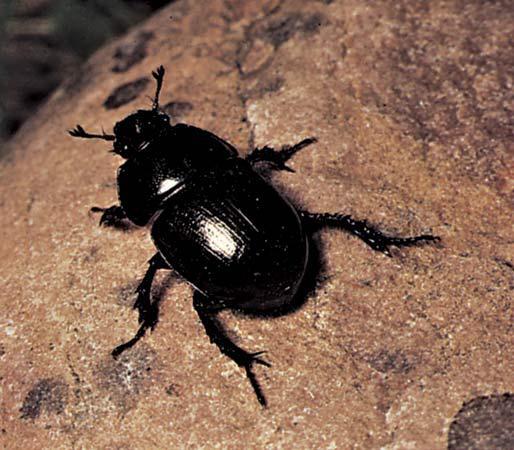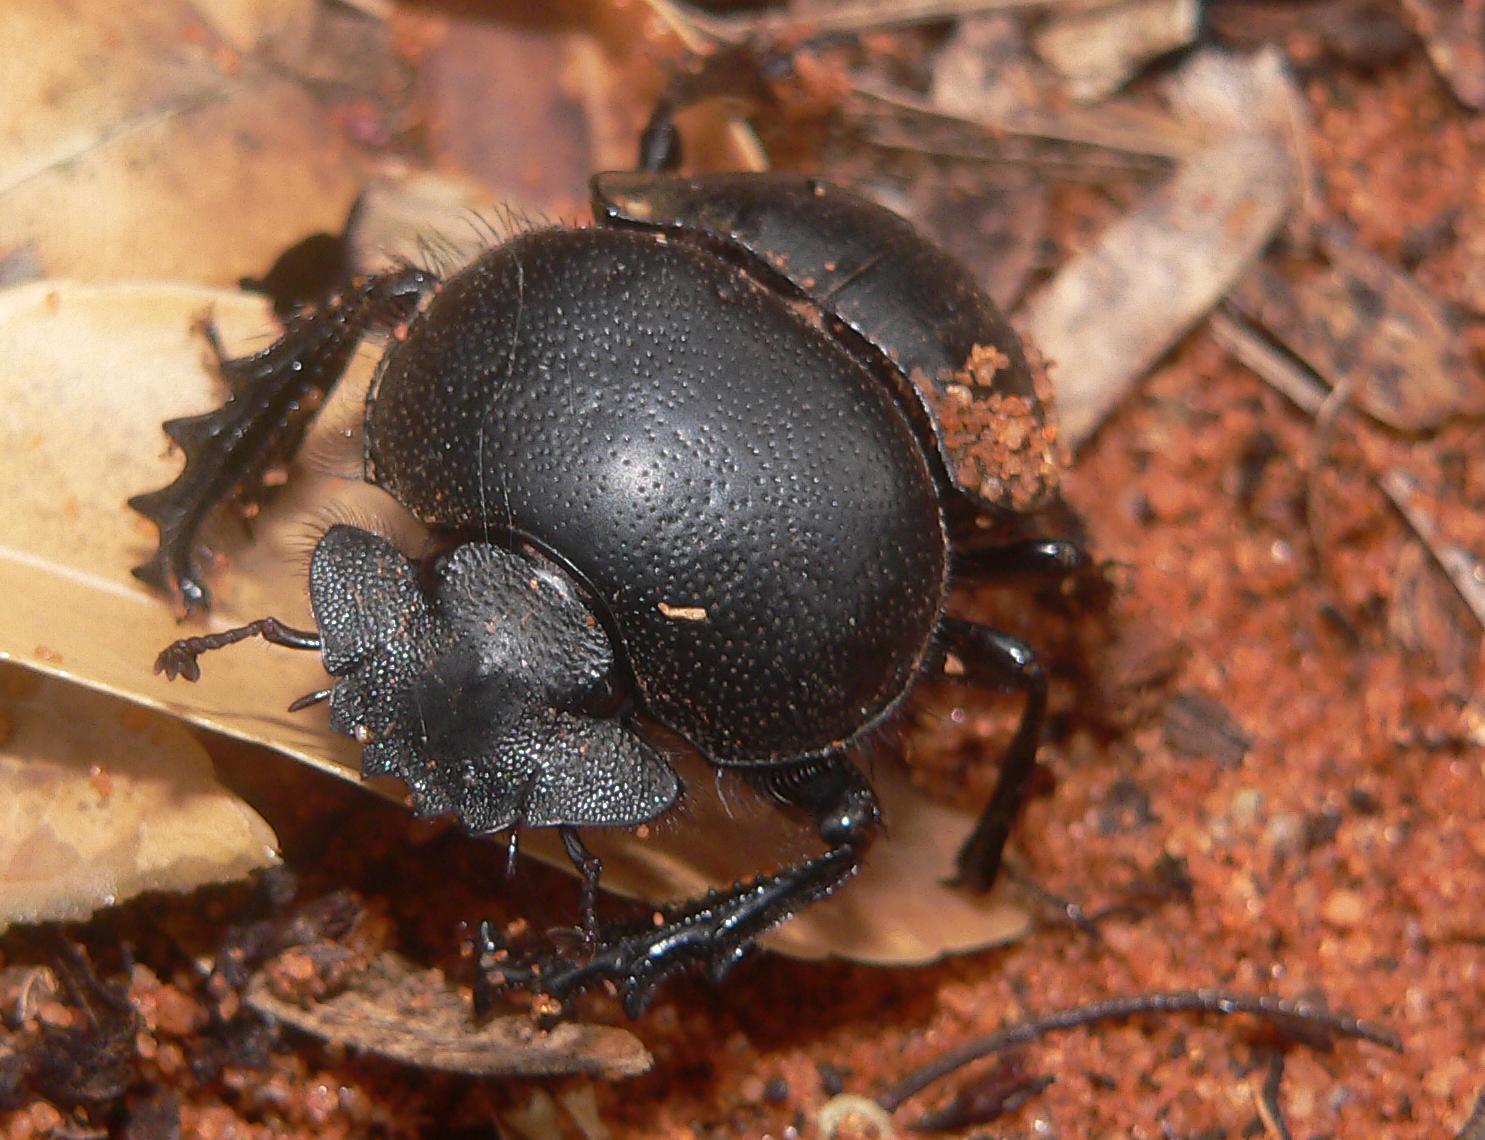The first image is the image on the left, the second image is the image on the right. Given the left and right images, does the statement "There are two beetles on a clod of dirt in one of the images." hold true? Answer yes or no. No. 